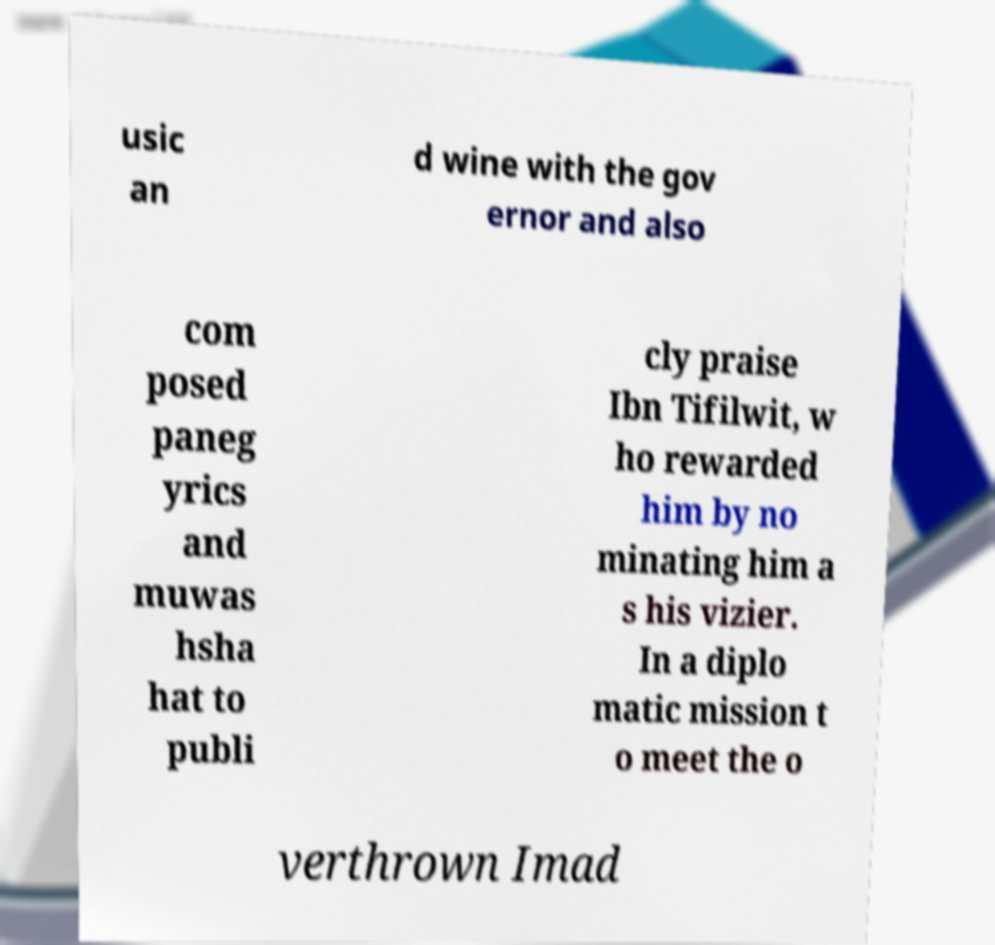Can you read and provide the text displayed in the image?This photo seems to have some interesting text. Can you extract and type it out for me? usic an d wine with the gov ernor and also com posed paneg yrics and muwas hsha hat to publi cly praise Ibn Tifilwit, w ho rewarded him by no minating him a s his vizier. In a diplo matic mission t o meet the o verthrown Imad 